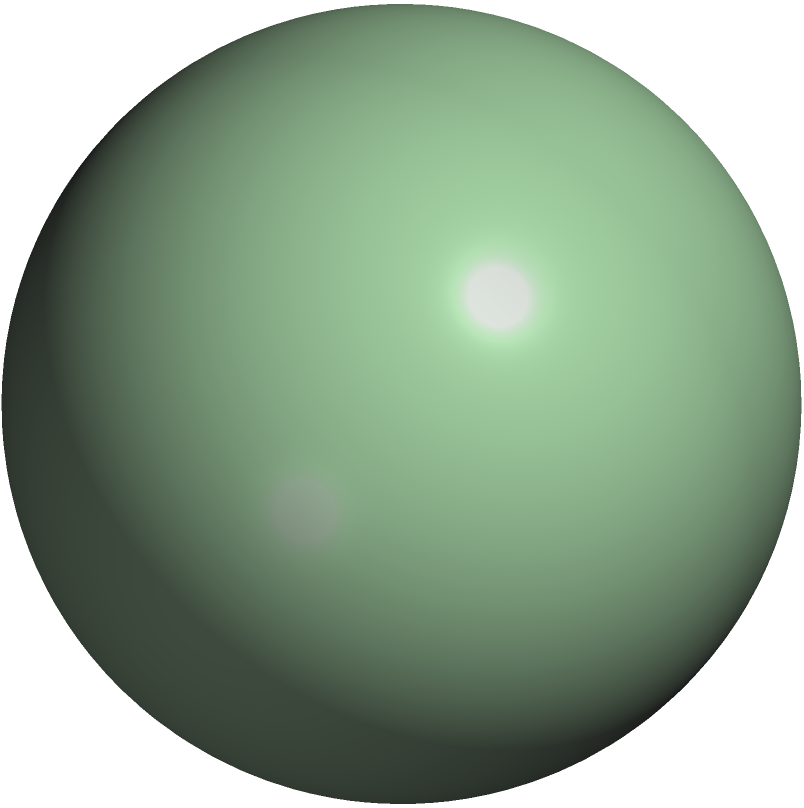Consider two historical sites A and B on Earth, where a particular religious belief spread. Site A is located at 60°N latitude and 30°E longitude, while site B is at 30°S latitude and 15°W longitude. Assuming Earth is a perfect sphere with a radius of 6371 km, what is the shortest distance along the surface of the Earth between these two sites? Round your answer to the nearest kilometer. To solve this problem, we need to use the great circle distance formula, which gives the shortest path between two points on a sphere. Here's the step-by-step solution:

1) Convert the coordinates to radians:
   A: $\phi_1 = 60° \cdot \frac{\pi}{180} = \frac{\pi}{3}$, $\lambda_1 = 30° \cdot \frac{\pi}{180} = \frac{\pi}{6}$
   B: $\phi_2 = -30° \cdot \frac{\pi}{180} = -\frac{\pi}{6}$, $\lambda_2 = -15° \cdot \frac{\pi}{180} = -\frac{\pi}{12}$

2) Calculate the central angle $\Delta\sigma$ using the Haversine formula:
   $\Delta\sigma = \arccos(\sin\phi_1 \sin\phi_2 + \cos\phi_1 \cos\phi_2 \cos(\Delta\lambda))$

   Where $\Delta\lambda = |\lambda_1 - \lambda_2| = |\frac{\pi}{6} - (-\frac{\pi}{12})| = \frac{\pi}{4}$

3) Substitute the values:
   $\Delta\sigma = \arccos(\sin(\frac{\pi}{3}) \sin(-\frac{\pi}{6}) + \cos(\frac{\pi}{3}) \cos(-\frac{\pi}{6}) \cos(\frac{\pi}{4}))$

4) Calculate:
   $\Delta\sigma \approx 1.6988$ radians

5) The distance $d$ along the great circle is:
   $d = R \cdot \Delta\sigma$
   Where $R$ is the radius of the Earth (6371 km)

6) Calculate the final distance:
   $d = 6371 \cdot 1.6988 \approx 10823.4$ km

7) Rounding to the nearest kilometer:
   $d \approx 10823$ km
Answer: 10823 km 